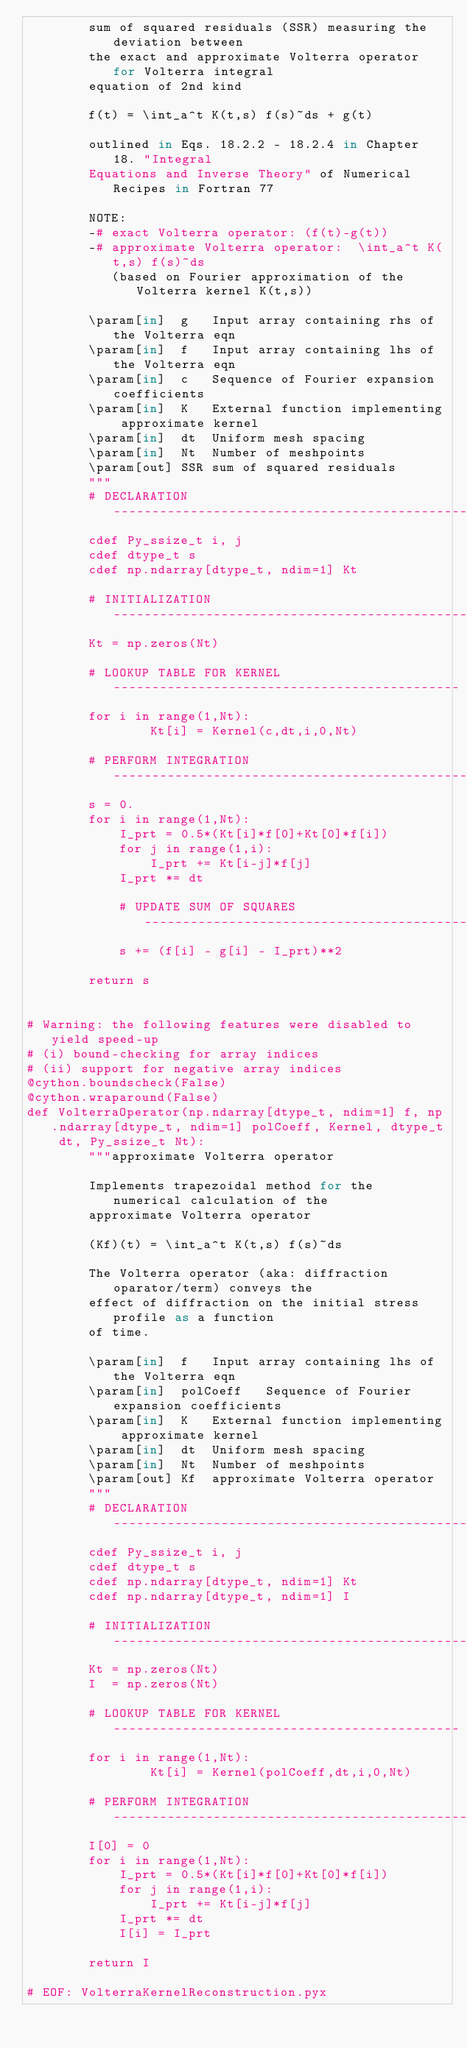<code> <loc_0><loc_0><loc_500><loc_500><_Cython_>        sum of squared residuals (SSR) measuring the deviation between 
        the exact and approximate Volterra operator for Volterra integral 
        equation of 2nd kind

        f(t) = \int_a^t K(t,s) f(s)~ds + g(t)

        outlined in Eqs. 18.2.2 - 18.2.4 in Chapter 18. "Integral 
        Equations and Inverse Theory" of Numerical Recipes in Fortran 77

        NOTE:
        -# exact Volterra operator: (f(t)-g(t))
        -# approximate Volterra operator:  \int_a^t K(t,s) f(s)~ds 
           (based on Fourier approximation of the Volterra kernel K(t,s))

        \param[in]  g   Input array containing rhs of the Volterra eqn
        \param[in]  f   Input array containing lhs of the Volterra eqn
        \param[in]  c   Sequence of Fourier expansion coefficients 
        \param[in]  K   External function implementing approximate kernel
        \param[in]  dt  Uniform mesh spacing 
        \param[in]  Nt  Number of meshpoints
        \param[out] SSR sum of squared residuals 
        """
        # DECLARATION ---------------------------------------------------------
        cdef Py_ssize_t i, j
        cdef dtype_t s
        cdef np.ndarray[dtype_t, ndim=1] Kt

        # INITIALIZATION ------------------------------------------------------
        Kt = np.zeros(Nt)   
        
        # LOOKUP TABLE FOR KERNEL ---------------------------------------------
        for i in range(1,Nt):
                Kt[i] = Kernel(c,dt,i,0,Nt)

        # PERFORM INTEGRATION -------------------------------------------------
        s = 0.
        for i in range(1,Nt):
            I_prt = 0.5*(Kt[i]*f[0]+Kt[0]*f[i])
            for j in range(1,i):
                I_prt += Kt[i-j]*f[j]
            I_prt *= dt
            
            # UPDATE SUM OF SQUARES ------------------------------------------- 
            s += (f[i] - g[i] - I_prt)**2

        return s


# Warning: the following features were disabled to yield speed-up
# (i) bound-checking for array indices
# (ii) support for negative array indices 
@cython.boundscheck(False)
@cython.wraparound(False)
def VolterraOperator(np.ndarray[dtype_t, ndim=1] f, np.ndarray[dtype_t, ndim=1] polCoeff, Kernel, dtype_t dt, Py_ssize_t Nt):
        """approximate Volterra operator

        Implements trapezoidal method for the numerical calculation of the
        approximate Volterra operator 

        (Kf)(t) = \int_a^t K(t,s) f(s)~ds 

        The Volterra operator (aka: diffraction oparator/term) conveys the
        effect of diffraction on the initial stress profile as a function
        of time.

        \param[in]  f   Input array containing lhs of the Volterra eqn
        \param[in]  polCoeff   Sequence of Fourier expansion coefficients 
        \param[in]  K   External function implementing approximate kernel
        \param[in]  dt  Uniform mesh spacing 
        \param[in]  Nt  Number of meshpoints
        \param[out] Kf  approximate Volterra operator 
        """
        # DECLARATION ---------------------------------------------------------
        cdef Py_ssize_t i, j
        cdef dtype_t s
        cdef np.ndarray[dtype_t, ndim=1] Kt
        cdef np.ndarray[dtype_t, ndim=1] I

        # INITIALIZATION ------------------------------------------------------
        Kt = np.zeros(Nt)   
        I  = np.zeros(Nt)   
        
        # LOOKUP TABLE FOR KERNEL ---------------------------------------------
        for i in range(1,Nt):
                Kt[i] = Kernel(polCoeff,dt,i,0,Nt)

        # PERFORM INTEGRATION -------------------------------------------------
        I[0] = 0
        for i in range(1,Nt):
            I_prt = 0.5*(Kt[i]*f[0]+Kt[0]*f[i])
            for j in range(1,i):
                I_prt += Kt[i-j]*f[j]
            I_prt *= dt
            I[i] = I_prt
            
        return I

# EOF: VolterraKernelReconstruction.pyx
</code> 